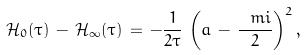<formula> <loc_0><loc_0><loc_500><loc_500>\mathcal { H } _ { 0 } ( \tau ) \, - \, \mathcal { H } _ { \infty } ( \tau ) \, = \, - \frac { 1 } { 2 \tau } \, \left ( a \, - \, \frac { \ m i } { 2 } \right ) ^ { 2 } ,</formula> 